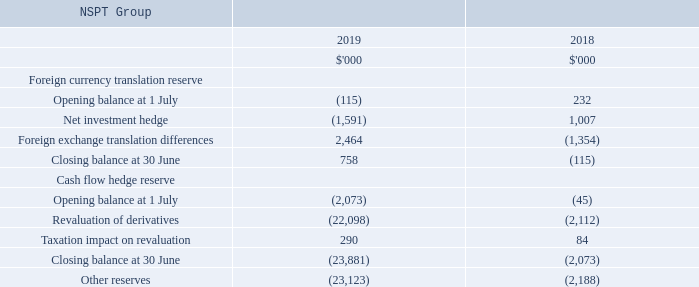The movements below in foreign currency translation reserve and cashflow hedge reserve relating to the NSPT Group are presented within non-controlling interest in the Group’s consolidated statement of changes in equity.
Taxation impact on revaluation applies only to cash flow hedges held in NSNZPT, a sub-trust of NSPT, which is subject to New Zealand tax legislation. Deferred tax does not apply to any other cash flow hedges held in the NSPT Group under current Australian tax legislation.
The hedging reserve is used to record gains or losses on derivatives that are designated as cash flow hedges and recognised in other comprehensive income, as described in note 2(m). Amounts are reclassified to profit or loss in the period when the associated hedged transaction takes place.
On 24 June 2019, the Group reset the interest rates associated with AUD denominated interest rate swaps designated as cash flow hedges. This resulted in a cash outflow of $22.9m which reduced the Group’s financial liability as presented in note 9.8. In accordance with AASB 9 Financial instruments, as the nature of the underlying hedged instrument is unchanged the fair value of this outflow remains in the cash flow hedge reserve and will be amortised to the statement of profit or loss in future periods.
The cash flow hedge is included in non-controlling interest in the Consolidated Group and is not classified within other reserves.
Where is the hedging reserve used? Record gains or losses on derivatives that are designated as cash flow hedges and recognised in other comprehensive income, as described in note 2(m). What was the cash outflow which reduced the Group's financial liability? $22.9m. What was the Net investment hedge in 2019 and 2018 respectively?
Answer scale should be: thousand. (1,591), 1,007. What was the average Foreign exchange translation differences for 2018 and 2019?
Answer scale should be: thousand. (2,464 - 1,354) / 2
Answer: 555. In which year is the Net investment hedge negative? Locate and analyze net investment hedge in row 6
answer: 2019. What is the change in the Taxation impact on revaluation from 2018 to 2019?
Answer scale should be: thousand. 290 - 84
Answer: 206. 